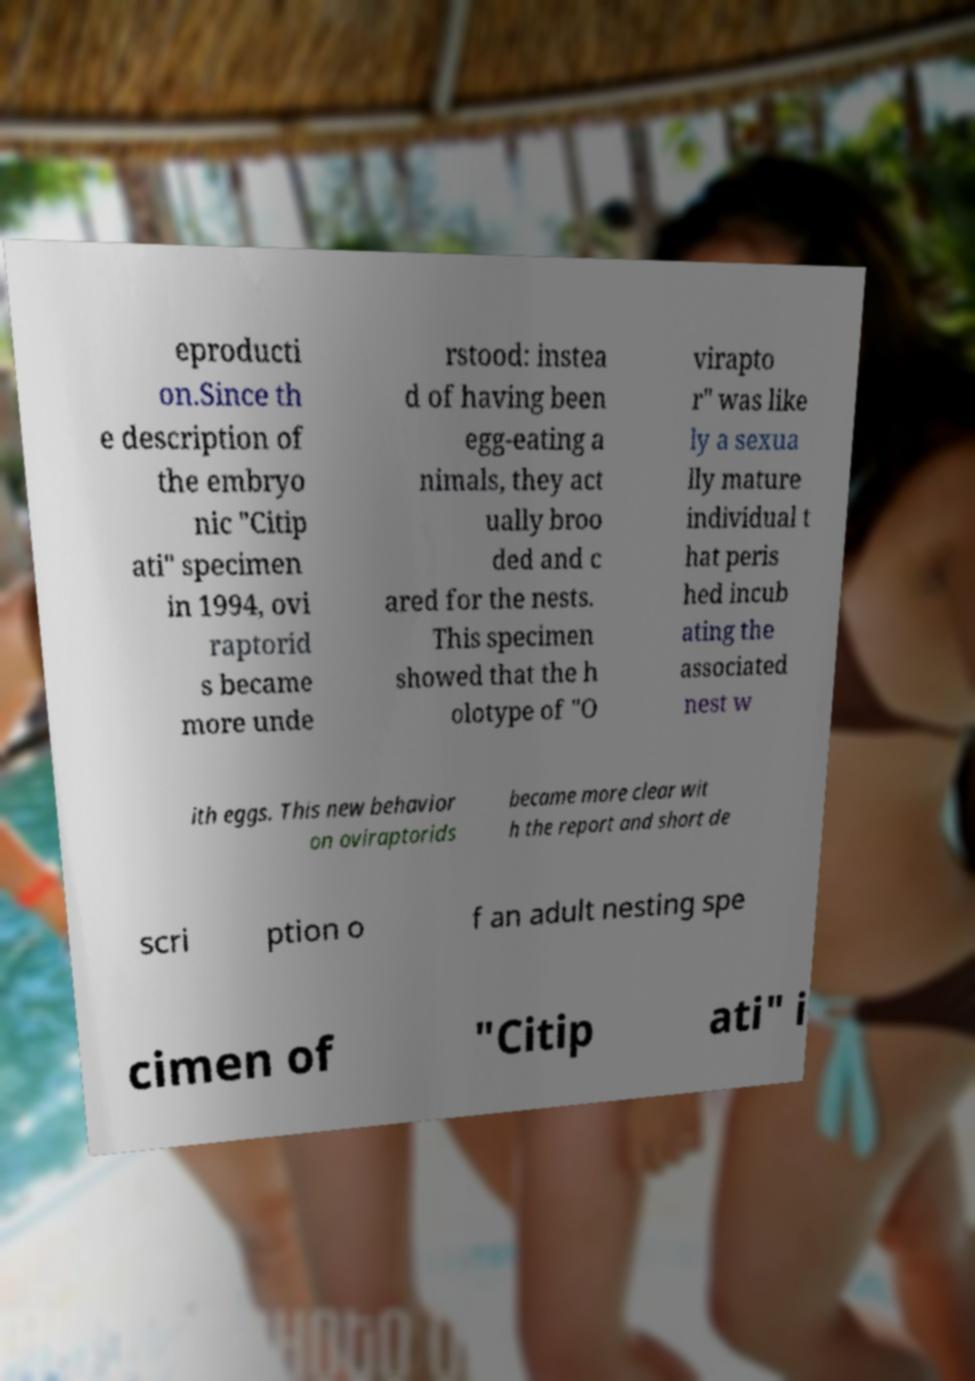For documentation purposes, I need the text within this image transcribed. Could you provide that? eproducti on.Since th e description of the embryo nic "Citip ati" specimen in 1994, ovi raptorid s became more unde rstood: instea d of having been egg-eating a nimals, they act ually broo ded and c ared for the nests. This specimen showed that the h olotype of "O virapto r" was like ly a sexua lly mature individual t hat peris hed incub ating the associated nest w ith eggs. This new behavior on oviraptorids became more clear wit h the report and short de scri ption o f an adult nesting spe cimen of "Citip ati" i 